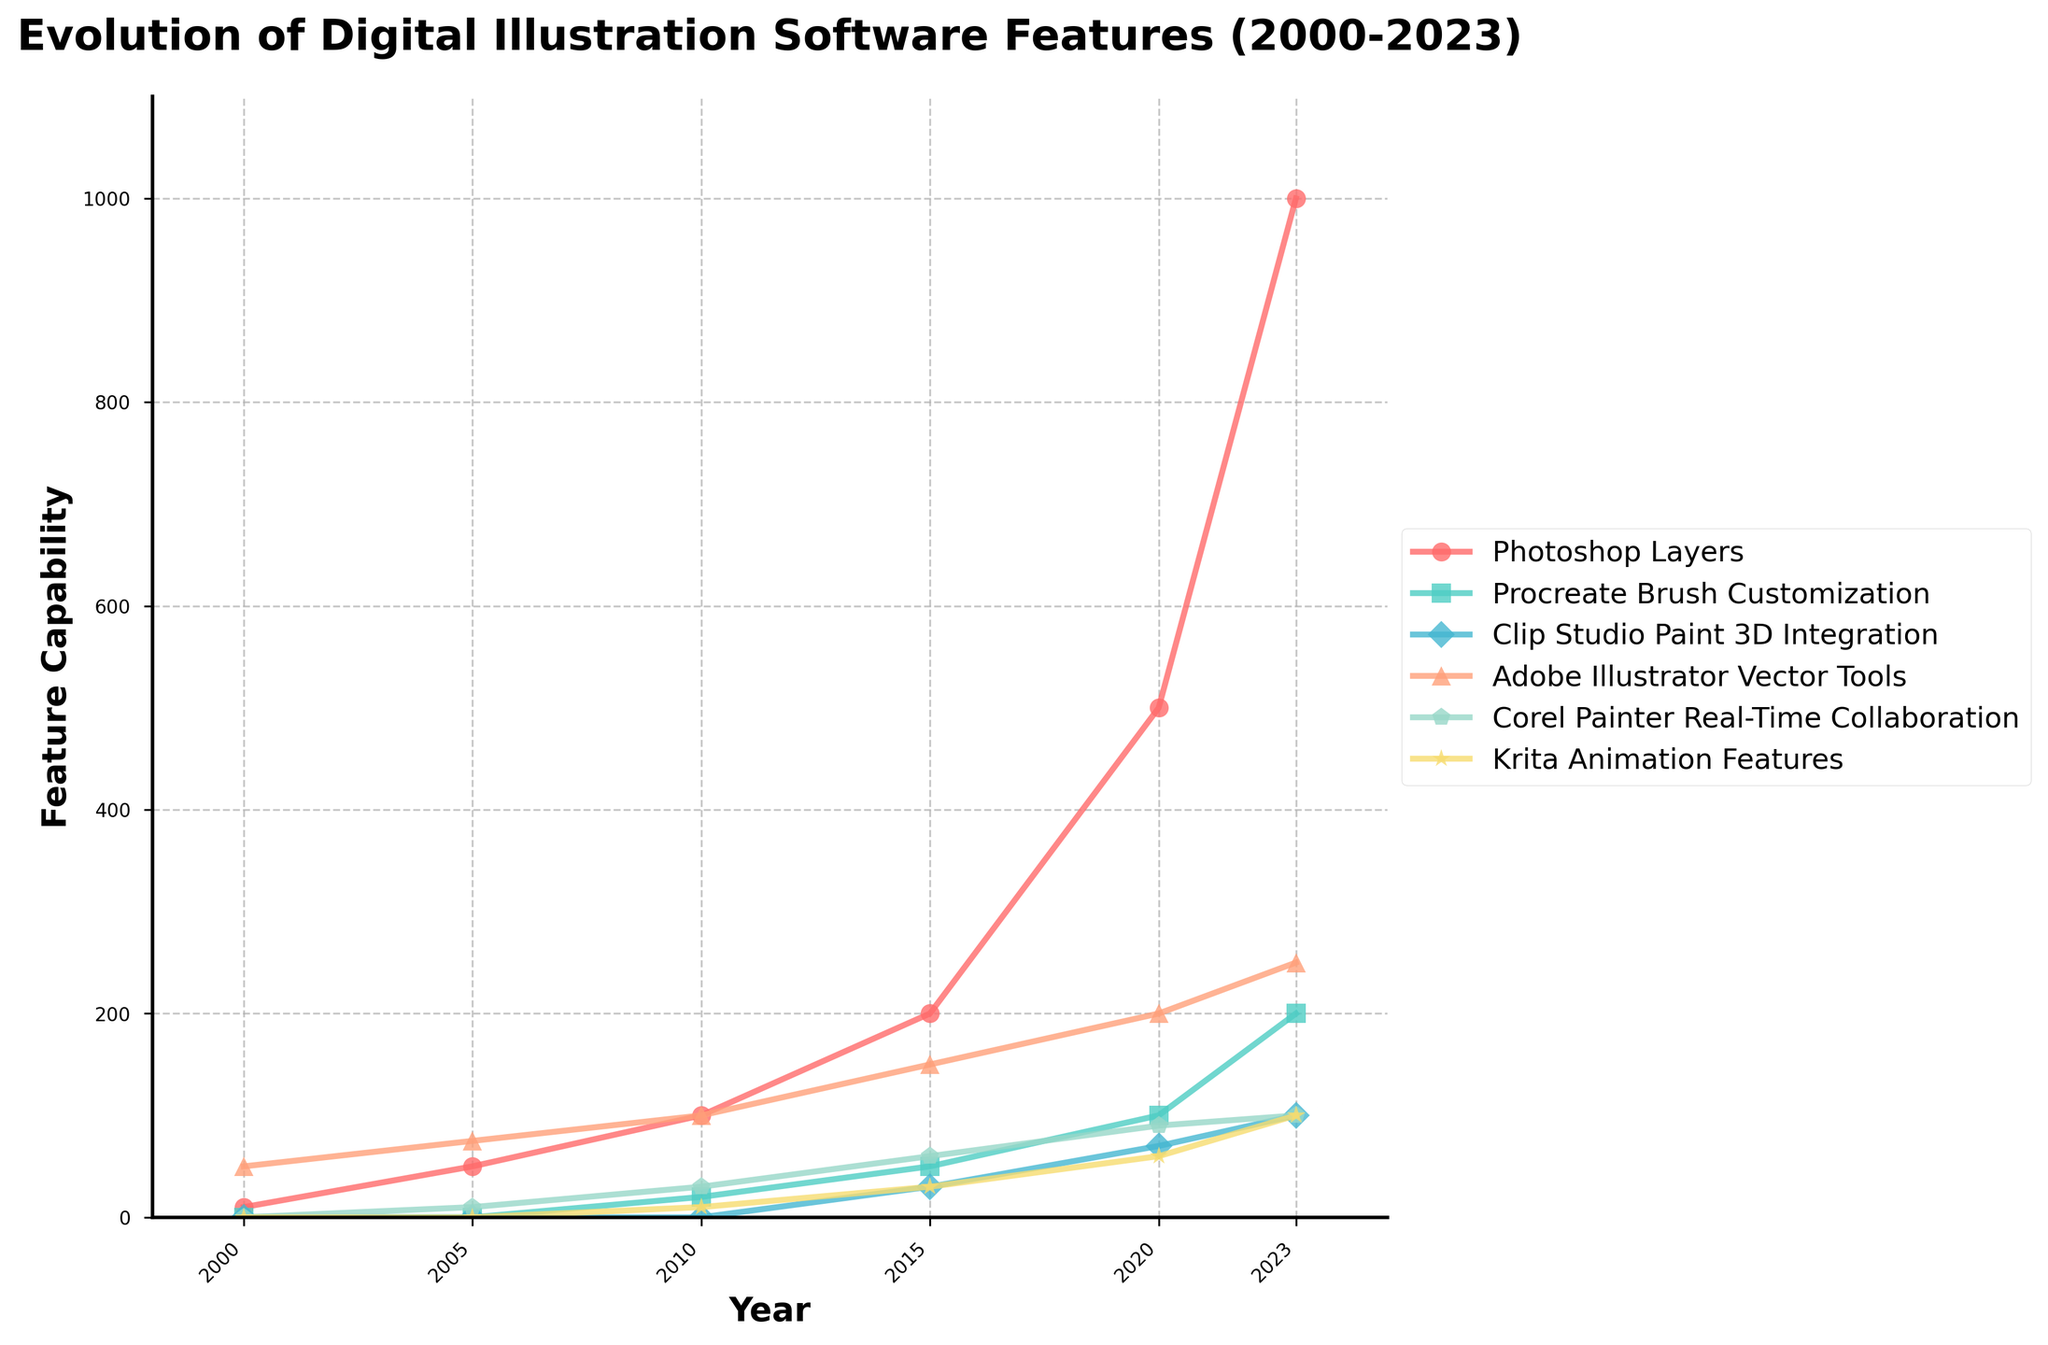What feature capability saw the most significant increase between 2000 and 2023? From the figure, observe the steepest upward trend. "Photoshop Layers" starts at 10 in 2000 and reaches 1000 in 2023, indicating the most significant increase.
Answer: Photoshop Layers How did "Procreate Brush Customization" feature change between 2010 and 2020? Check the values for Procreate Brush Customization in 2010 and 2020. In 2010, it was at 20, and by 2020, it reached 100, showing an increase of 80.
Answer: It increased by 80 By 2023, which feature has the highest capability, and which one has the lowest? Compare the values for all features in 2023. "Photoshop Layers" is at 1000, the highest, while "Corel Painter Real-Time Collaboration" and "Krita Animation Features" are both at 100, the lowest.
Answer: Highest: Photoshop Layers, Lowest: Corel Painter Real-Time Collaboration/Krita Animation Features Which two features had the same capability in 2023? Look for equal values across different features in 2023. "Corel Painter Real-Time Collaboration" and "Krita Animation Features" both stand at 100.
Answer: Corel Painter Real-Time Collaboration and Krita Animation Features What is the average capability of "Clip Studio Paint 3D Integration" from 2000 to 2023? Sum the values of "Clip Studio Paint 3D Integration" from each year (0+0+0+30+70+100) and divide by the number of data points (6). The sum is 200, giving an average of 200/6 ≈ 33.33.
Answer: 33.33 Between 2005 and 2015, which feature's capability increased the most? Calculate the capability difference for each feature between 2005 and 2015: 
- Photoshop Layers: 200 - 50 = 150
- Procreate Brush Customization: 50 - 0 = 50
- Clip Studio Paint 3D Integration: 30 - 0 = 30
- Adobe Illustrator Vector Tools: 150 - 75 = 75
- Corel Painter Real-Time Collaboration: 60 - 10 = 50
- Krita Animation Features: 30 - 0 = 30
The "Photoshop Layers" feature increased the most with a difference of 150.
Answer: Photoshop Layers Which feature had no capability in 2000 and saw the highest capability in 2023? Determine which features start at 0 in 2000 and observe their value in 2023. "Procreate Brush Customization," "Clip Studio Paint 3D Integration," "Corel Painter Real-Time Collaboration," and "Krita Animation Features" start at 0; among them, "Procreate Brush Customization" reaches 200 in 2023.
Answer: Procreate Brush Customization How much has "Adobe Illustrator Vector Tools" capability increased from 2000 to 2023? Subtract the 2000 value from the 2023 value for "Adobe Illustrator Vector Tools". Thus, 250 - 50 = 200.
Answer: 200 In 2015, which two features had the closest values, and what were their differences? Compare features' values in 2015:
- Photoshop Layers: 200
- Procreate Brush Customization: 50
- Clip Studio Paint 3D Integration: 30
- Adobe Illustrator Vector Tools: 150
- Corel Painter Real-Time Collaboration: 60
- Krita Animation Features: 30
The closest values are "Clip Studio Paint 3D Integration" and "Krita Animation Features," both at 30, with a difference of 0.
Answer: Clip Studio Paint 3D Integration and Krita Animation Features, 0 Which feature showed an uninterrupted increase in capability from 2000 to 2023? Identify features that exhibit a consistent upward trend without drops. "Photoshop Layers" shows a continuous increase from 10 to 1000 over the years.
Answer: Photoshop Layers 